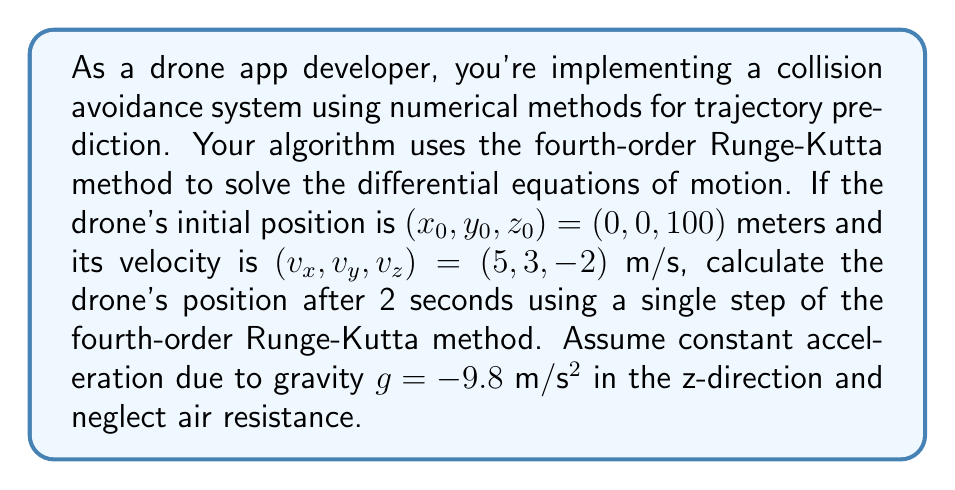Show me your answer to this math problem. To solve this problem, we'll use the fourth-order Runge-Kutta method (RK4) to approximate the drone's position after 2 seconds. The equations of motion for the drone are:

$$\frac{dx}{dt} = v_x$$
$$\frac{dy}{dt} = v_y$$
$$\frac{dz}{dt} = v_z$$
$$\frac{dv_x}{dt} = 0$$
$$\frac{dv_y}{dt} = 0$$
$$\frac{dv_z}{dt} = g = -9.8$$

Let's define our state vector as $\mathbf{y} = [x, y, z, v_x, v_y, v_z]^T$. The RK4 method is given by:

$$\mathbf{y}_{n+1} = \mathbf{y}_n + \frac{1}{6}(k_1 + 2k_2 + 2k_3 + k_4)$$

Where:
$$k_1 = h f(\mathbf{y}_n)$$
$$k_2 = h f(\mathbf{y}_n + \frac{1}{2}k_1)$$
$$k_3 = h f(\mathbf{y}_n + \frac{1}{2}k_2)$$
$$k_4 = h f(\mathbf{y}_n + k_3)$$

Here, $h$ is the step size (2 seconds in our case), and $f(\mathbf{y})$ is our system of differential equations.

Step 1: Calculate $k_1$
$$k_1 = h \begin{bmatrix} 
5 \\ 3 \\ -2 \\ 0 \\ 0 \\ -9.8
\end{bmatrix} = \begin{bmatrix} 
10 \\ 6 \\ -4 \\ 0 \\ 0 \\ -19.6
\end{bmatrix}$$

Step 2: Calculate $k_2$
$$k_2 = h f(\mathbf{y}_n + \frac{1}{2}k_1) = h \begin{bmatrix} 
5 \\ 3 \\ -2 - 9.8 \\ 0 \\ 0 \\ -9.8
\end{bmatrix} = \begin{bmatrix} 
10 \\ 6 \\ -23.6 \\ 0 \\ 0 \\ -19.6
\end{bmatrix}$$

Step 3: Calculate $k_3$
$$k_3 = h f(\mathbf{y}_n + \frac{1}{2}k_2) = h \begin{bmatrix} 
5 \\ 3 \\ -2 - 9.8 \\ 0 \\ 0 \\ -9.8
\end{bmatrix} = \begin{bmatrix} 
10 \\ 6 \\ -23.6 \\ 0 \\ 0 \\ -19.6
\end{bmatrix}$$

Step 4: Calculate $k_4$
$$k_4 = h f(\mathbf{y}_n + k_3) = h \begin{bmatrix} 
5 \\ 3 \\ -2 - 19.6 \\ 0 \\ 0 \\ -9.8
\end{bmatrix} = \begin{bmatrix} 
10 \\ 6 \\ -43.2 \\ 0 \\ 0 \\ -19.6
\end{bmatrix}$$

Step 5: Calculate the final position
$$\mathbf{y}_{n+1} = \mathbf{y}_n + \frac{1}{6}(k_1 + 2k_2 + 2k_3 + k_4)$$

$$\begin{bmatrix} 
x \\ y \\ z \\ v_x \\ v_y \\ v_z
\end{bmatrix}_{n+1} = \begin{bmatrix} 
0 \\ 0 \\ 100 \\ 5 \\ 3 \\ -2
\end{bmatrix} + \frac{1}{6}\begin{bmatrix} 
10 + 20 + 20 + 10 \\ 6 + 12 + 12 + 6 \\ -4 - 47.2 - 47.2 - 43.2 \\ 0 \\ 0 \\ -19.6 - 39.2 - 39.2 - 19.6
\end{bmatrix}$$

$$\begin{bmatrix} 
x \\ y \\ z \\ v_x \\ v_y \\ v_z
\end{bmatrix}_{n+1} = \begin{bmatrix} 
10 \\ 6 \\ 76.4 \\ 5 \\ 3 \\ -21.6
\end{bmatrix}$$

Therefore, the drone's position after 2 seconds is $(10, 6, 76.4)$ meters.
Answer: $(10, 6, 76.4)$ meters 